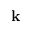<formula> <loc_0><loc_0><loc_500><loc_500>k</formula> 